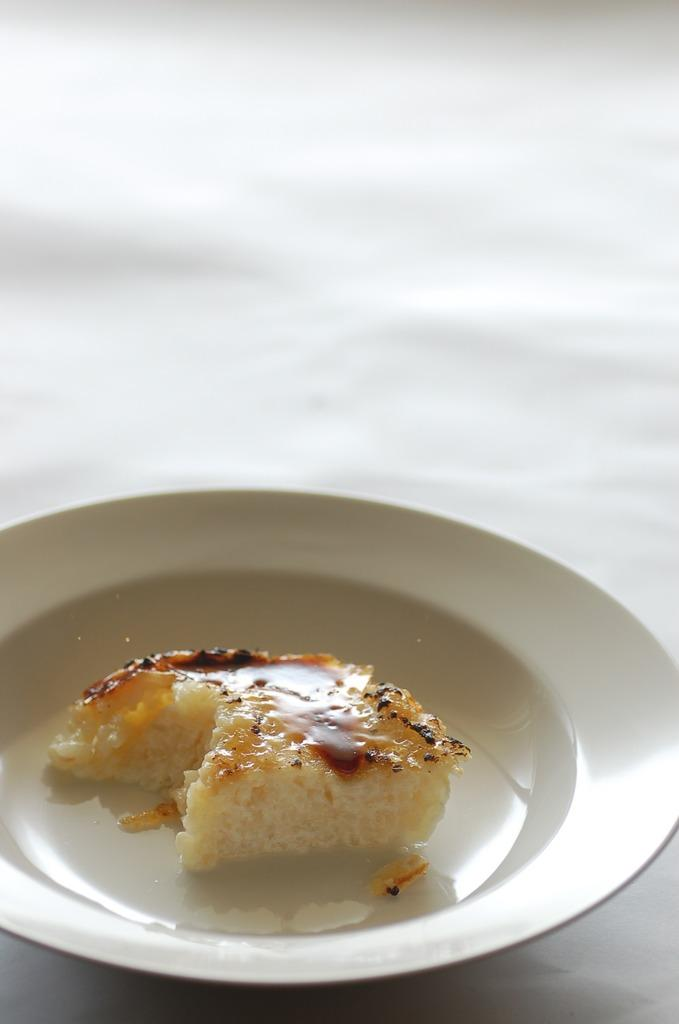What is on the plate that is visible in the image? There is food in a plate in the image. What color is the background of the image? The background of the image is white in color. What type of pleasure can be seen enjoying the food in the image? There is no indication of pleasure or any sentient beings in the image, as it only features food on a plate and a white background. What type of skin is visible on the food in the image? There is no skin present in the image, as it only features food on a plate. What type of boot is visible in the image? There is no boot present in the image. 